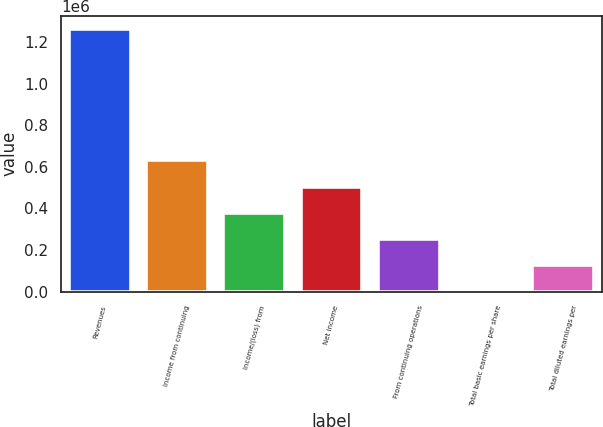Convert chart. <chart><loc_0><loc_0><loc_500><loc_500><bar_chart><fcel>Revenues<fcel>Income from continuing<fcel>Income/(loss) from<fcel>Net income<fcel>From continuing operations<fcel>Total basic earnings per share<fcel>Total diluted earnings per<nl><fcel>1.26258e+06<fcel>631289<fcel>378774<fcel>505031<fcel>252516<fcel>1.07<fcel>126259<nl></chart> 